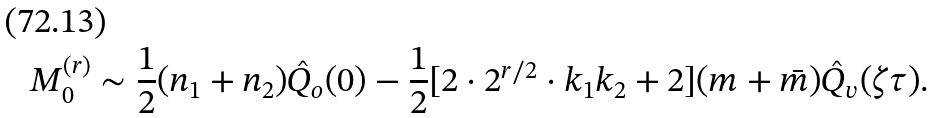Convert formula to latex. <formula><loc_0><loc_0><loc_500><loc_500>M _ { 0 } ^ { ( r ) } \sim \frac { 1 } { 2 } ( n _ { 1 } + n _ { 2 } ) \hat { Q } _ { o } ( 0 ) - \frac { 1 } { 2 } [ 2 \cdot 2 ^ { r / 2 } \cdot k _ { 1 } k _ { 2 } + 2 ] ( m + \bar { m } ) \hat { Q } _ { v } ( \zeta \tau ) .</formula> 